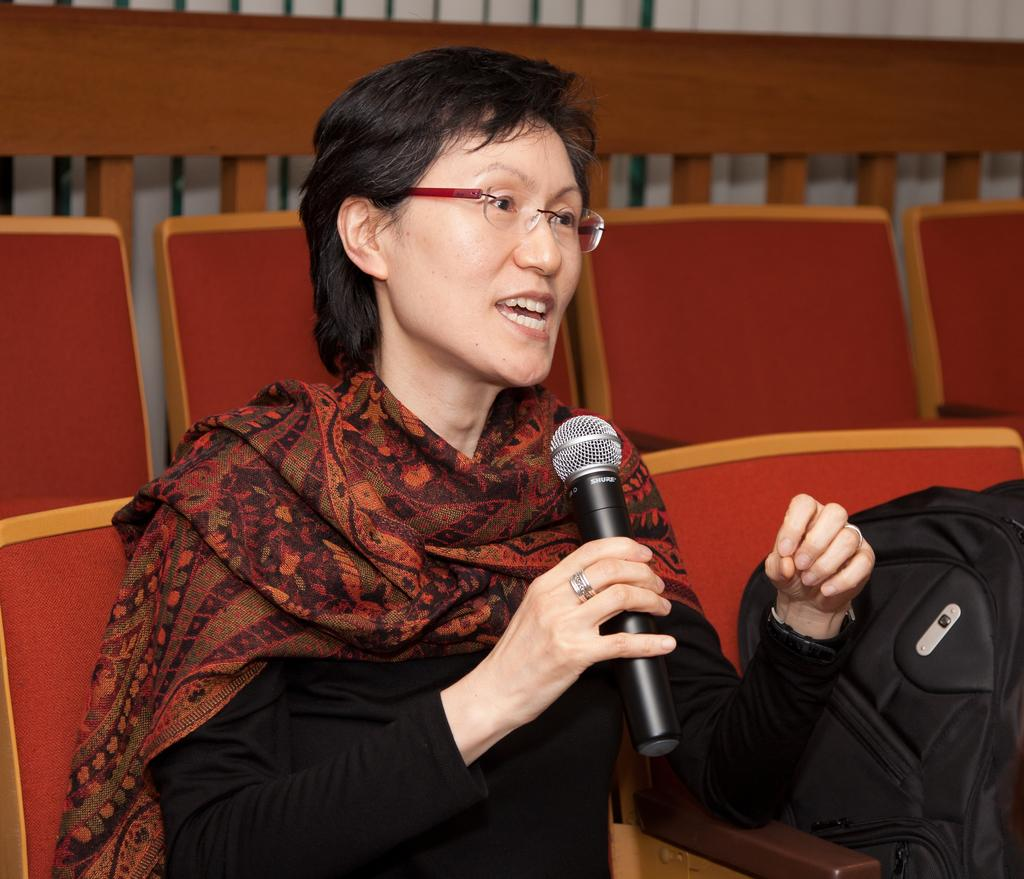What is the man in the image doing? The man is sitting on a chair in the image. What is the man holding in the image? The man is holding a microphone. What can be seen in the background of the image? There are chairs in the background of the image. What object is visible near the man in the image? There is a bag visible in the image. What can be observed about the woman in the image? The woman (presumably the speaker) is wearing spectacles. What type of playground equipment can be seen in the image? There is no playground equipment present in the image. What part of the man's body is being tasted in the image? There is no indication in the image that any part of the man's body is being tasted. 